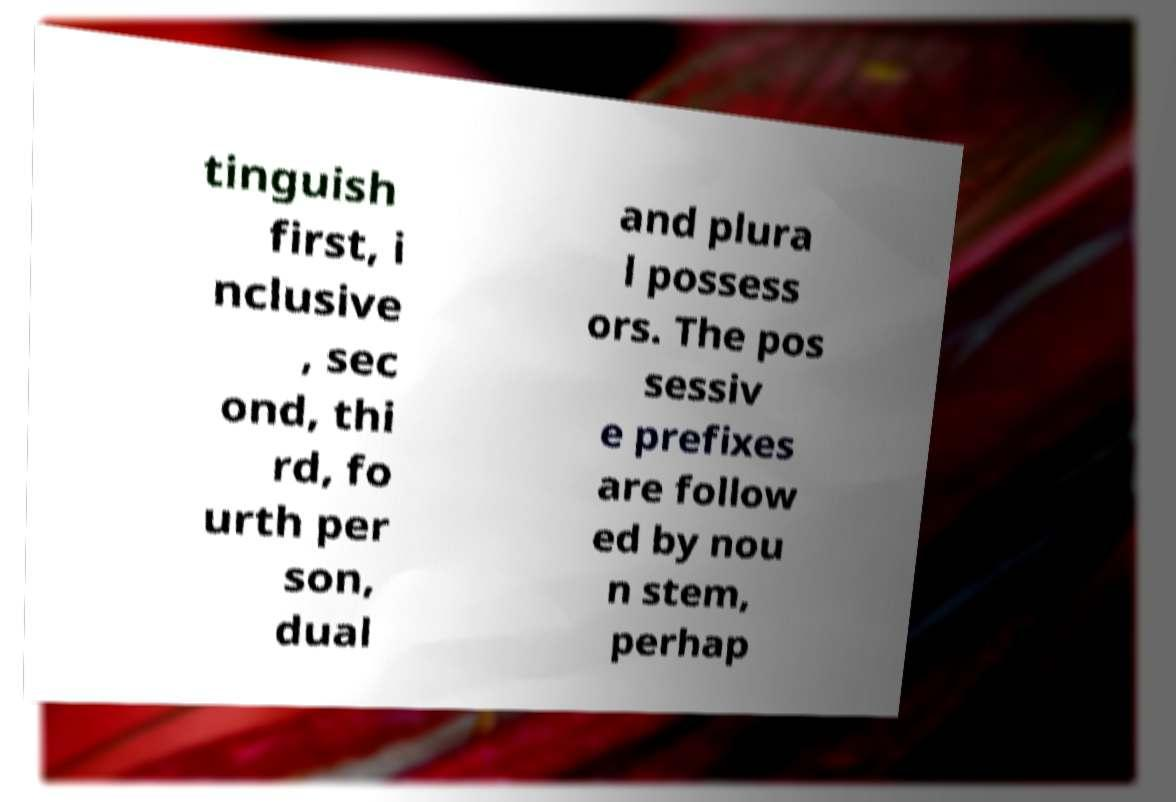There's text embedded in this image that I need extracted. Can you transcribe it verbatim? tinguish first, i nclusive , sec ond, thi rd, fo urth per son, dual and plura l possess ors. The pos sessiv e prefixes are follow ed by nou n stem, perhap 